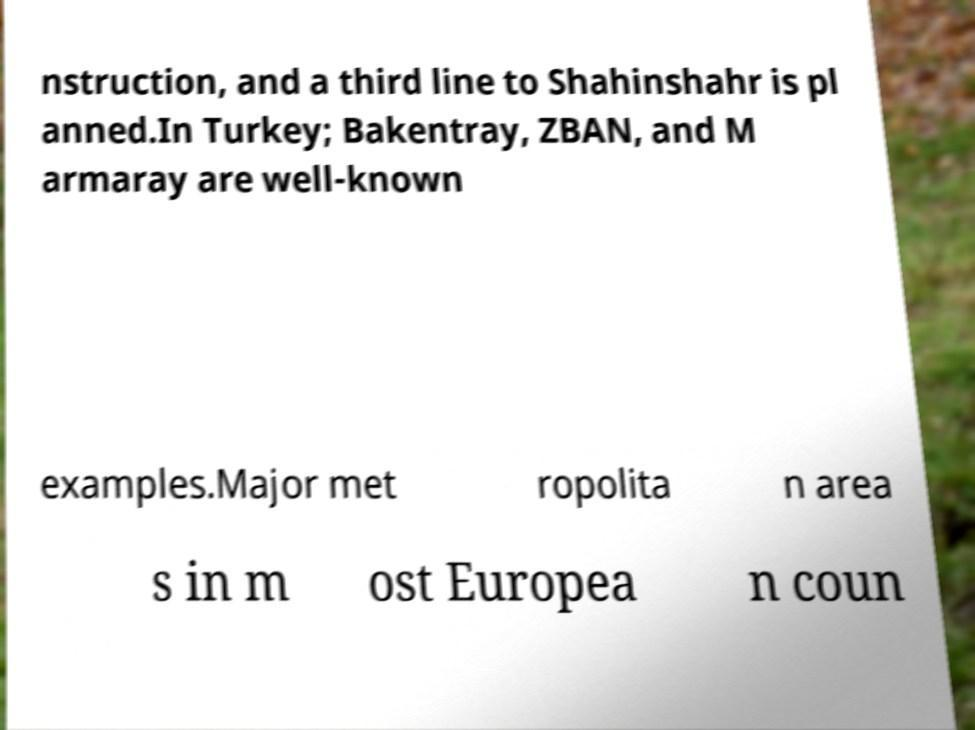Please read and relay the text visible in this image. What does it say? nstruction, and a third line to Shahinshahr is pl anned.In Turkey; Bakentray, ZBAN, and M armaray are well-known examples.Major met ropolita n area s in m ost Europea n coun 